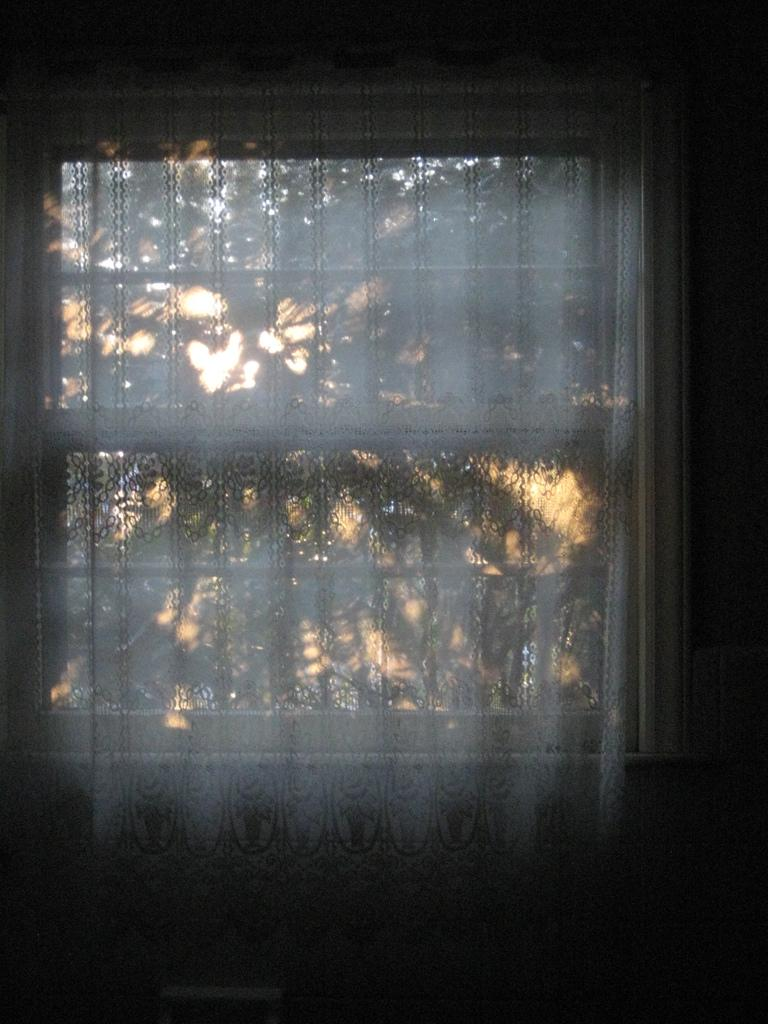What can be seen in the image that allows light to enter a room? There is a window in the image that allows light to enter a room. What type of window treatment is present in the image? The window treatment in the image consists of white curtains. What can be seen in the background of the image? There are trees visible in the background of the image. What is the color of the curtains in the image? The curtains in the image are white. How many beds can be seen in the image? There are no beds present in the image. What type of key is used to unlock the window in the image? There is no key mentioned or visible in the image, as the window does not require a key to open or close. 